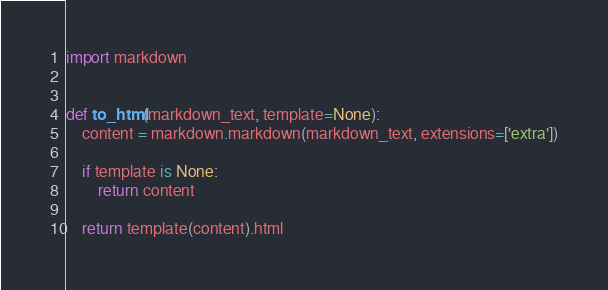Convert code to text. <code><loc_0><loc_0><loc_500><loc_500><_Python_>import markdown


def to_html(markdown_text, template=None):
    content = markdown.markdown(markdown_text, extensions=['extra'])

    if template is None:
        return content

    return template(content).html
</code> 